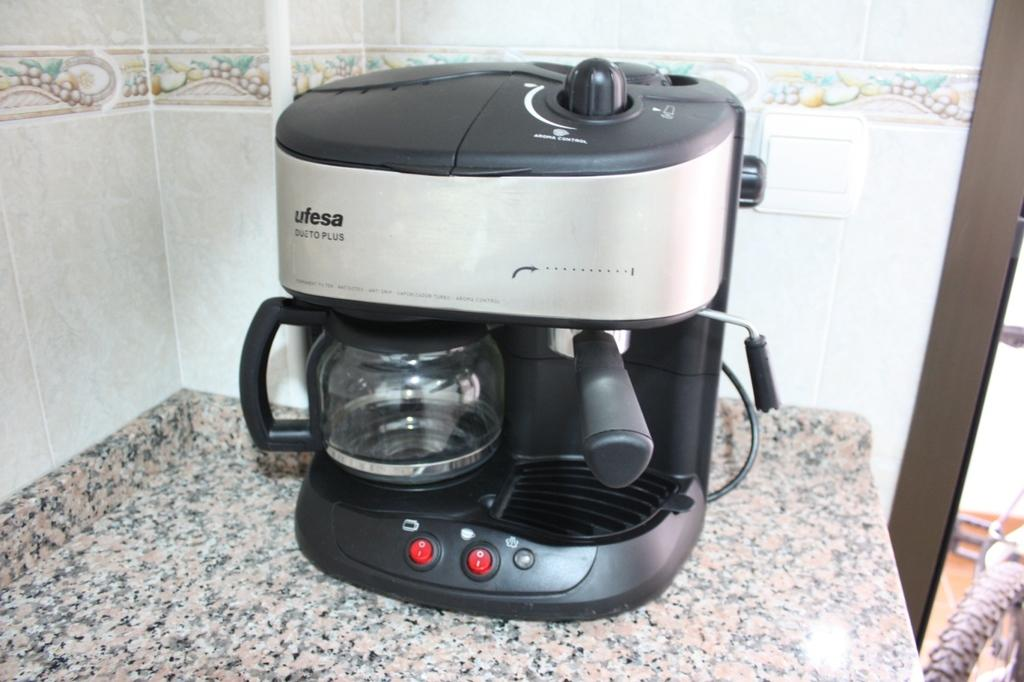<image>
Share a concise interpretation of the image provided. A black and silver espresso maker made by ufesa. 